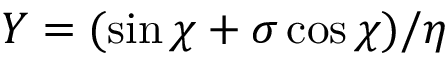Convert formula to latex. <formula><loc_0><loc_0><loc_500><loc_500>Y = ( \sin \chi + \sigma \cos \chi ) / \eta</formula> 